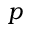Convert formula to latex. <formula><loc_0><loc_0><loc_500><loc_500>p</formula> 